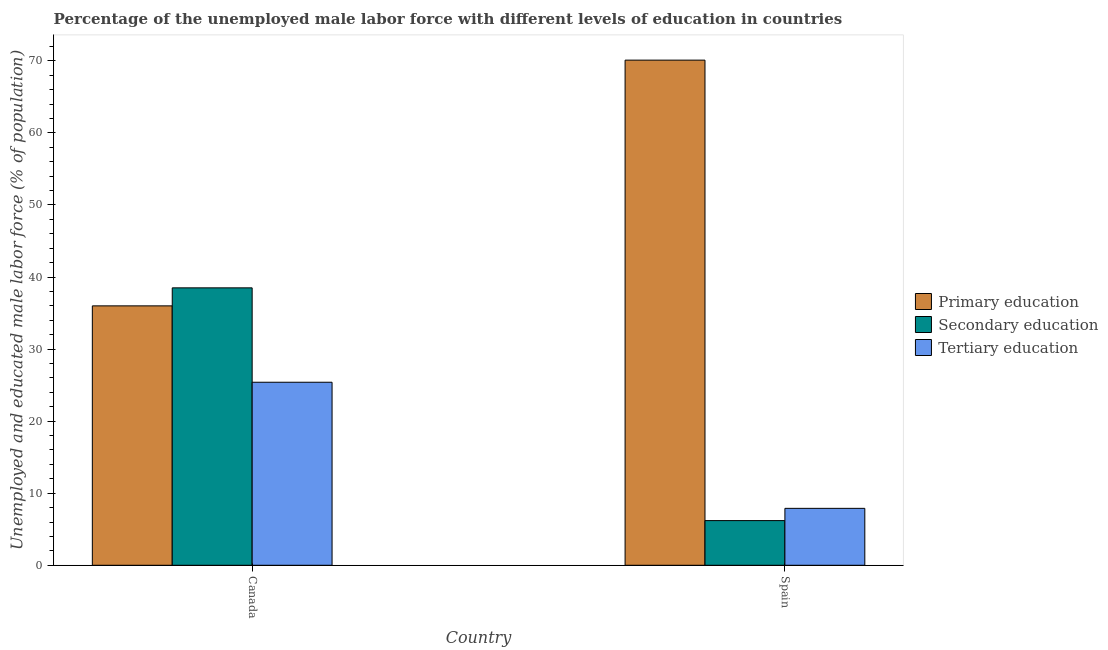In how many cases, is the number of bars for a given country not equal to the number of legend labels?
Offer a terse response. 0. What is the percentage of male labor force who received primary education in Spain?
Make the answer very short. 70.1. Across all countries, what is the maximum percentage of male labor force who received primary education?
Offer a very short reply. 70.1. Across all countries, what is the minimum percentage of male labor force who received primary education?
Keep it short and to the point. 36. In which country was the percentage of male labor force who received primary education maximum?
Your answer should be compact. Spain. In which country was the percentage of male labor force who received primary education minimum?
Ensure brevity in your answer.  Canada. What is the total percentage of male labor force who received tertiary education in the graph?
Keep it short and to the point. 33.3. What is the difference between the percentage of male labor force who received tertiary education in Canada and that in Spain?
Keep it short and to the point. 17.5. What is the difference between the percentage of male labor force who received tertiary education in Canada and the percentage of male labor force who received secondary education in Spain?
Ensure brevity in your answer.  19.2. What is the average percentage of male labor force who received primary education per country?
Make the answer very short. 53.05. What is the difference between the percentage of male labor force who received secondary education and percentage of male labor force who received tertiary education in Canada?
Provide a short and direct response. 13.1. What is the ratio of the percentage of male labor force who received secondary education in Canada to that in Spain?
Keep it short and to the point. 6.21. In how many countries, is the percentage of male labor force who received tertiary education greater than the average percentage of male labor force who received tertiary education taken over all countries?
Provide a succinct answer. 1. What does the 2nd bar from the right in Canada represents?
Make the answer very short. Secondary education. Are all the bars in the graph horizontal?
Your answer should be very brief. No. How many countries are there in the graph?
Ensure brevity in your answer.  2. Does the graph contain any zero values?
Offer a very short reply. No. Does the graph contain grids?
Provide a succinct answer. No. How many legend labels are there?
Offer a very short reply. 3. How are the legend labels stacked?
Your response must be concise. Vertical. What is the title of the graph?
Your response must be concise. Percentage of the unemployed male labor force with different levels of education in countries. What is the label or title of the X-axis?
Provide a succinct answer. Country. What is the label or title of the Y-axis?
Your answer should be very brief. Unemployed and educated male labor force (% of population). What is the Unemployed and educated male labor force (% of population) of Primary education in Canada?
Make the answer very short. 36. What is the Unemployed and educated male labor force (% of population) of Secondary education in Canada?
Keep it short and to the point. 38.5. What is the Unemployed and educated male labor force (% of population) of Tertiary education in Canada?
Keep it short and to the point. 25.4. What is the Unemployed and educated male labor force (% of population) of Primary education in Spain?
Ensure brevity in your answer.  70.1. What is the Unemployed and educated male labor force (% of population) in Secondary education in Spain?
Offer a terse response. 6.2. What is the Unemployed and educated male labor force (% of population) in Tertiary education in Spain?
Provide a succinct answer. 7.9. Across all countries, what is the maximum Unemployed and educated male labor force (% of population) in Primary education?
Provide a succinct answer. 70.1. Across all countries, what is the maximum Unemployed and educated male labor force (% of population) of Secondary education?
Offer a terse response. 38.5. Across all countries, what is the maximum Unemployed and educated male labor force (% of population) in Tertiary education?
Give a very brief answer. 25.4. Across all countries, what is the minimum Unemployed and educated male labor force (% of population) in Secondary education?
Provide a succinct answer. 6.2. Across all countries, what is the minimum Unemployed and educated male labor force (% of population) in Tertiary education?
Ensure brevity in your answer.  7.9. What is the total Unemployed and educated male labor force (% of population) in Primary education in the graph?
Offer a terse response. 106.1. What is the total Unemployed and educated male labor force (% of population) in Secondary education in the graph?
Make the answer very short. 44.7. What is the total Unemployed and educated male labor force (% of population) of Tertiary education in the graph?
Provide a succinct answer. 33.3. What is the difference between the Unemployed and educated male labor force (% of population) in Primary education in Canada and that in Spain?
Give a very brief answer. -34.1. What is the difference between the Unemployed and educated male labor force (% of population) in Secondary education in Canada and that in Spain?
Provide a succinct answer. 32.3. What is the difference between the Unemployed and educated male labor force (% of population) in Tertiary education in Canada and that in Spain?
Make the answer very short. 17.5. What is the difference between the Unemployed and educated male labor force (% of population) of Primary education in Canada and the Unemployed and educated male labor force (% of population) of Secondary education in Spain?
Offer a very short reply. 29.8. What is the difference between the Unemployed and educated male labor force (% of population) in Primary education in Canada and the Unemployed and educated male labor force (% of population) in Tertiary education in Spain?
Your response must be concise. 28.1. What is the difference between the Unemployed and educated male labor force (% of population) of Secondary education in Canada and the Unemployed and educated male labor force (% of population) of Tertiary education in Spain?
Make the answer very short. 30.6. What is the average Unemployed and educated male labor force (% of population) of Primary education per country?
Offer a terse response. 53.05. What is the average Unemployed and educated male labor force (% of population) of Secondary education per country?
Your response must be concise. 22.35. What is the average Unemployed and educated male labor force (% of population) in Tertiary education per country?
Ensure brevity in your answer.  16.65. What is the difference between the Unemployed and educated male labor force (% of population) of Primary education and Unemployed and educated male labor force (% of population) of Tertiary education in Canada?
Make the answer very short. 10.6. What is the difference between the Unemployed and educated male labor force (% of population) of Primary education and Unemployed and educated male labor force (% of population) of Secondary education in Spain?
Offer a terse response. 63.9. What is the difference between the Unemployed and educated male labor force (% of population) of Primary education and Unemployed and educated male labor force (% of population) of Tertiary education in Spain?
Ensure brevity in your answer.  62.2. What is the ratio of the Unemployed and educated male labor force (% of population) in Primary education in Canada to that in Spain?
Give a very brief answer. 0.51. What is the ratio of the Unemployed and educated male labor force (% of population) in Secondary education in Canada to that in Spain?
Your response must be concise. 6.21. What is the ratio of the Unemployed and educated male labor force (% of population) in Tertiary education in Canada to that in Spain?
Your response must be concise. 3.22. What is the difference between the highest and the second highest Unemployed and educated male labor force (% of population) of Primary education?
Ensure brevity in your answer.  34.1. What is the difference between the highest and the second highest Unemployed and educated male labor force (% of population) of Secondary education?
Offer a very short reply. 32.3. What is the difference between the highest and the lowest Unemployed and educated male labor force (% of population) in Primary education?
Your answer should be compact. 34.1. What is the difference between the highest and the lowest Unemployed and educated male labor force (% of population) in Secondary education?
Make the answer very short. 32.3. 